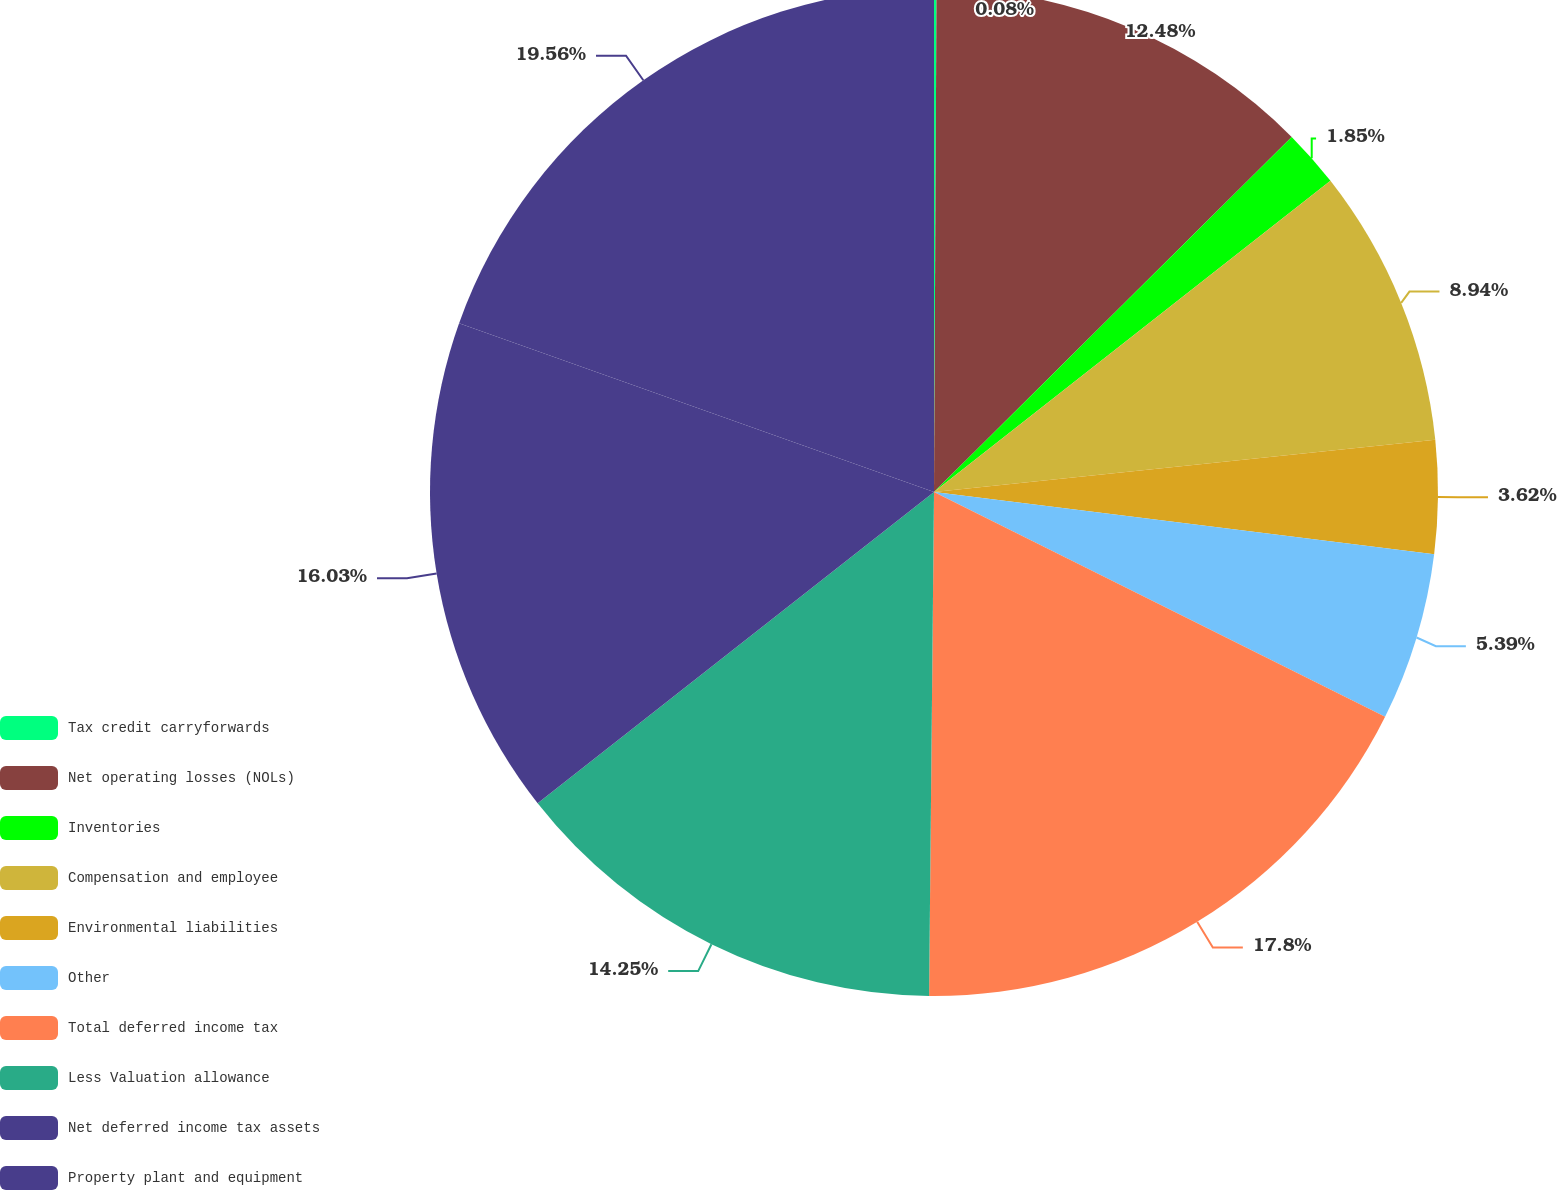Convert chart. <chart><loc_0><loc_0><loc_500><loc_500><pie_chart><fcel>Tax credit carryforwards<fcel>Net operating losses (NOLs)<fcel>Inventories<fcel>Compensation and employee<fcel>Environmental liabilities<fcel>Other<fcel>Total deferred income tax<fcel>Less Valuation allowance<fcel>Net deferred income tax assets<fcel>Property plant and equipment<nl><fcel>0.08%<fcel>12.48%<fcel>1.85%<fcel>8.94%<fcel>3.62%<fcel>5.39%<fcel>17.8%<fcel>14.25%<fcel>16.03%<fcel>19.57%<nl></chart> 